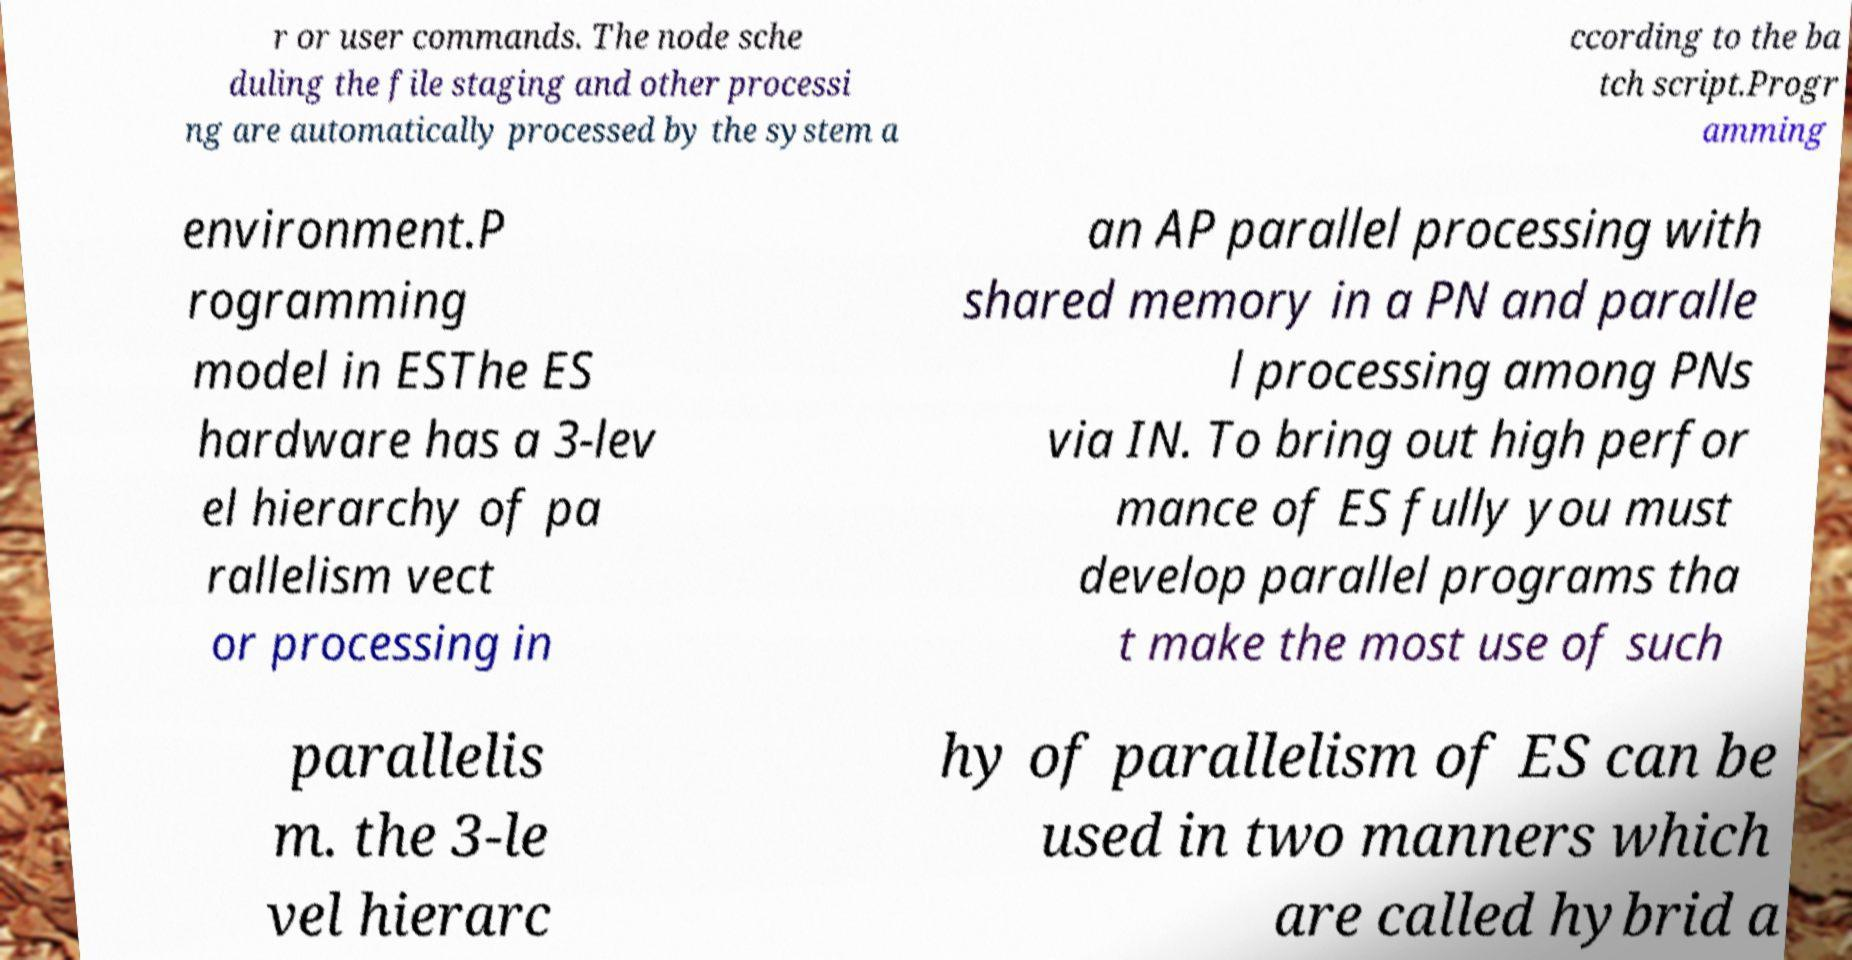Could you extract and type out the text from this image? r or user commands. The node sche duling the file staging and other processi ng are automatically processed by the system a ccording to the ba tch script.Progr amming environment.P rogramming model in ESThe ES hardware has a 3-lev el hierarchy of pa rallelism vect or processing in an AP parallel processing with shared memory in a PN and paralle l processing among PNs via IN. To bring out high perfor mance of ES fully you must develop parallel programs tha t make the most use of such parallelis m. the 3-le vel hierarc hy of parallelism of ES can be used in two manners which are called hybrid a 